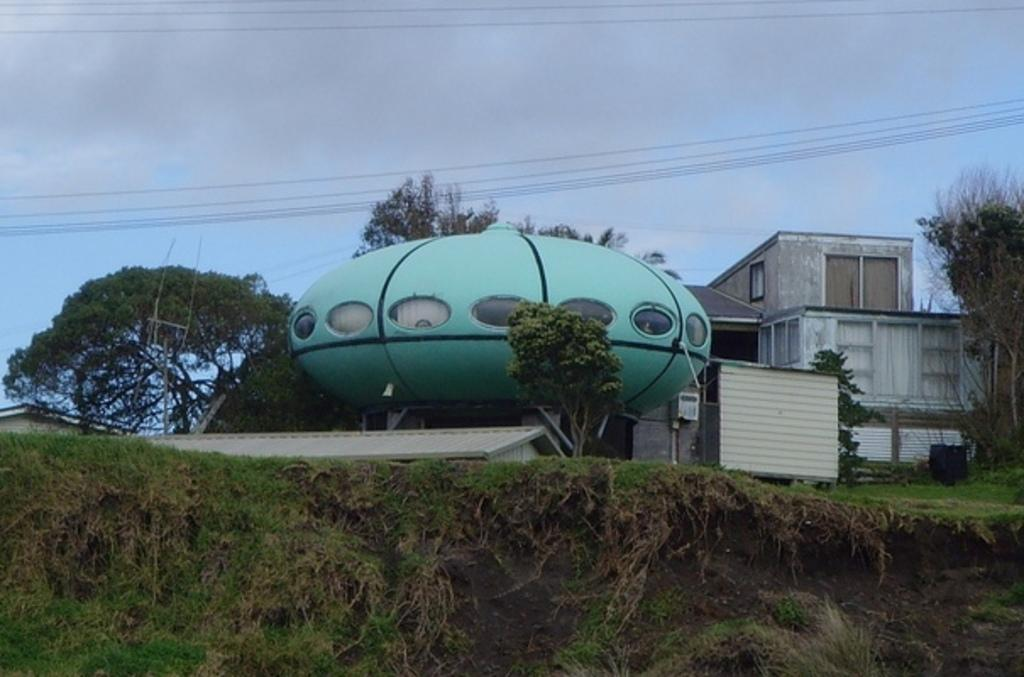What type of structures are present in the image? There are buildings with windows in the image. What other natural elements can be seen in the image? There are trees in the image. Are there any man-made objects visible in the image? Yes, there are wires in the image. What can be seen in the background of the image? The sky with clouds is visible in the background of the image. What type of drug is being sold in the image? There is no indication of any drug being sold or present in the image. 